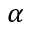<formula> <loc_0><loc_0><loc_500><loc_500>\alpha</formula> 